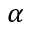<formula> <loc_0><loc_0><loc_500><loc_500>\alpha</formula> 